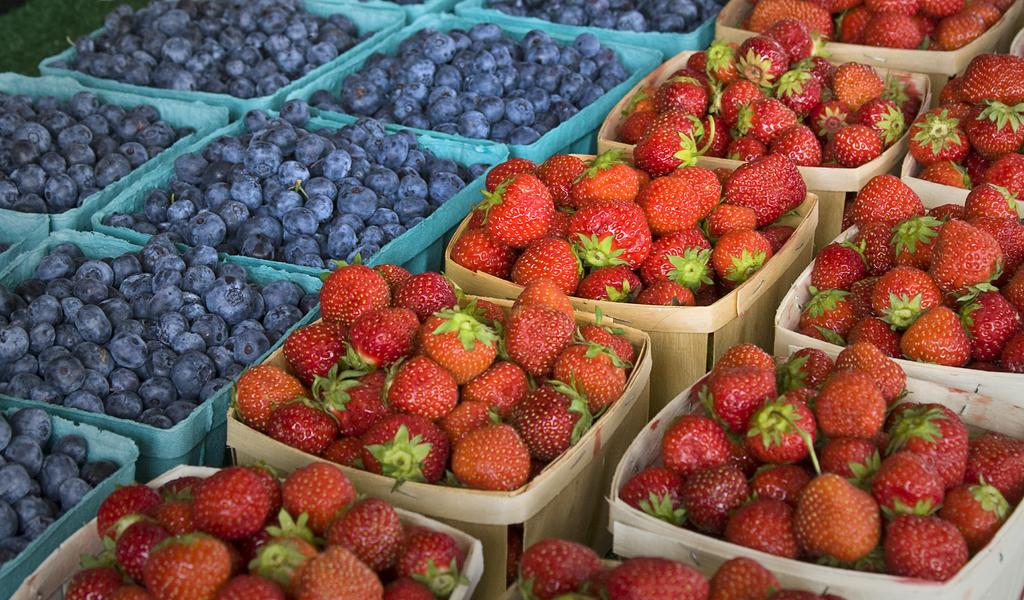What objects can be seen in the image? There are baskets in the image. How are the baskets on the right side different from those on the left side? The baskets on the right side are full of strawberries, while the baskets on the left side contain blueberries. Are there any dinosaurs or horses playing with the balls in the image? There are no dinosaurs, horses, or balls present in the image. 